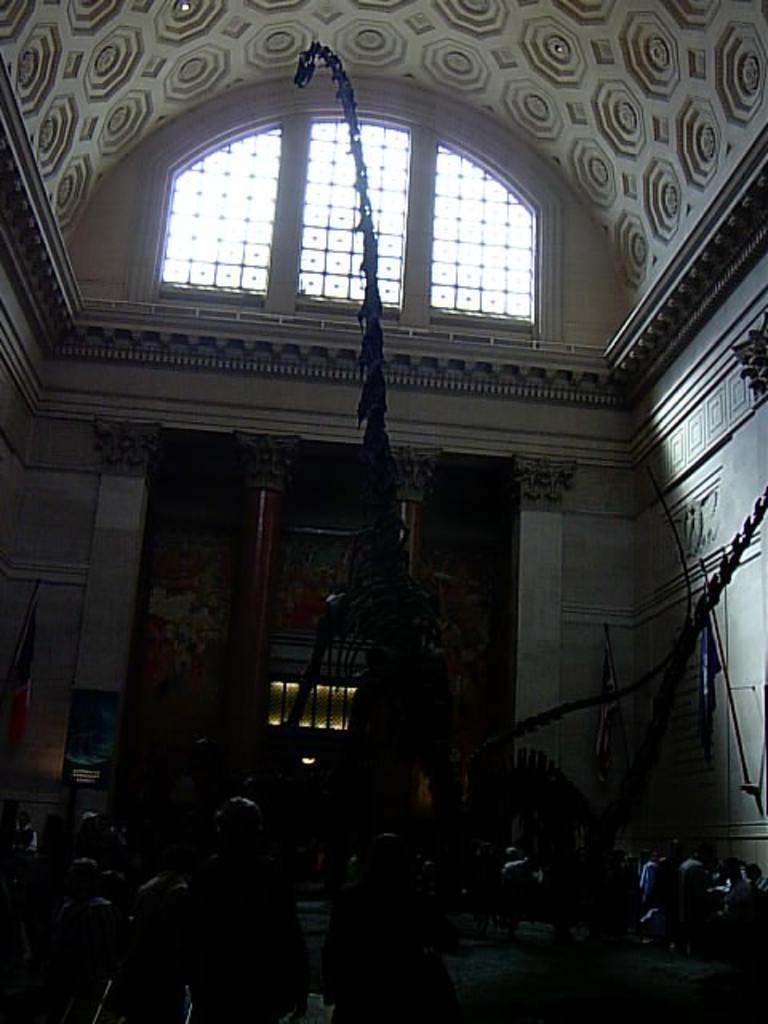How would you summarize this image in a sentence or two? In the picture we can see a building inside it, we can see some people are sitting on the chairs near the tables and some people are standing and in the background, we can see a two pillars which are brown in color and top of it, we can see a ventilator and to the ceiling there are some designs and to the walls also we can see some designs. 